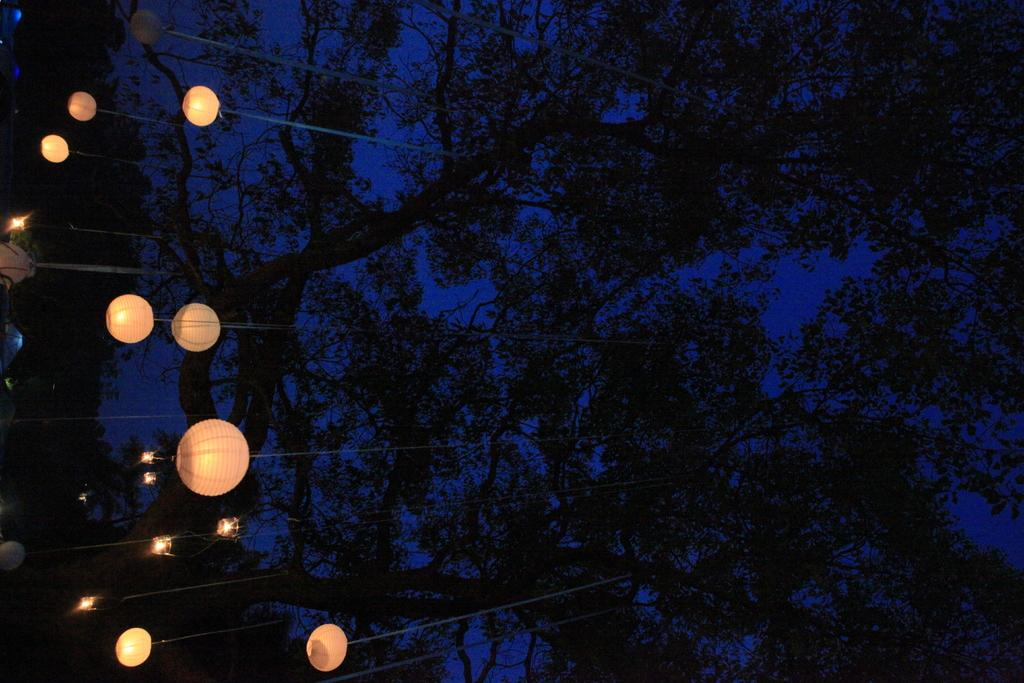What can be seen on the left side of the image? There are lights on the left side of the image. What is located on the right side of the image? There are trees on the right side of the image. What is visible in the background of the image? The sky is visible in the background of the image. Where is the rock located in the image? There is no rock present in the image. What type of cub can be seen playing in the image? There is no cub present in the image. 